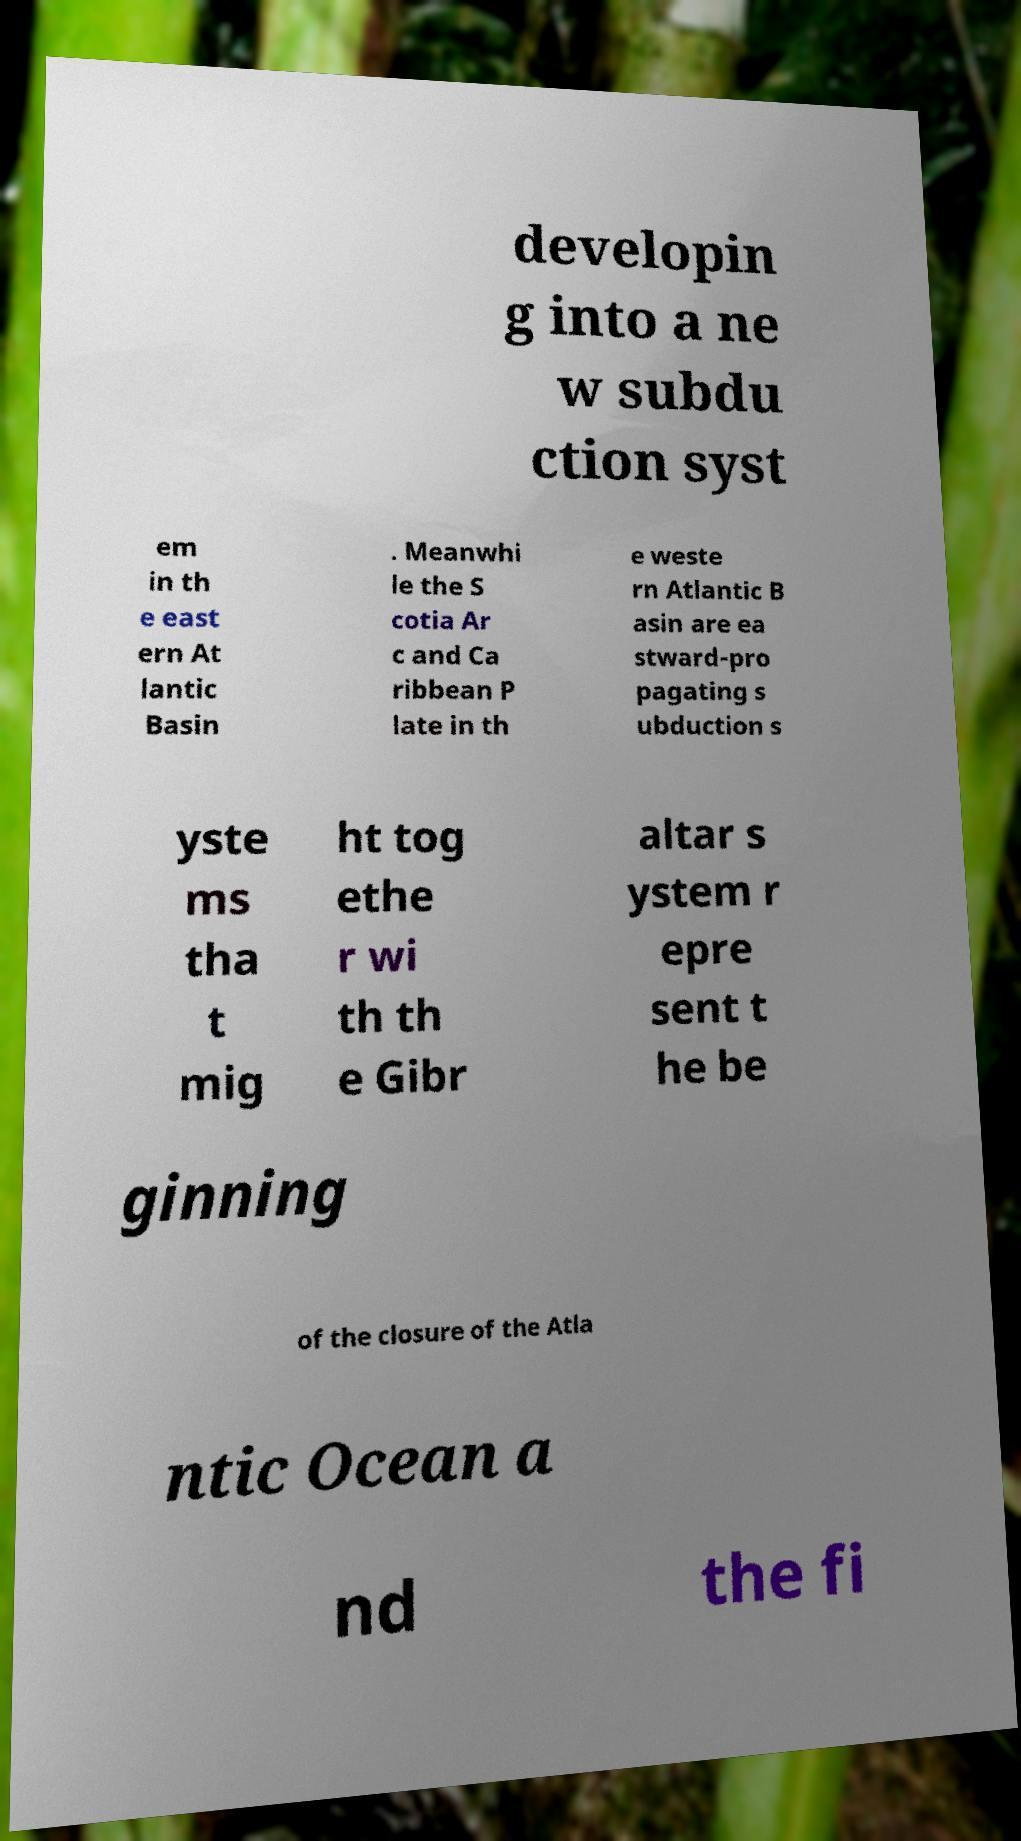Please read and relay the text visible in this image. What does it say? developin g into a ne w subdu ction syst em in th e east ern At lantic Basin . Meanwhi le the S cotia Ar c and Ca ribbean P late in th e weste rn Atlantic B asin are ea stward-pro pagating s ubduction s yste ms tha t mig ht tog ethe r wi th th e Gibr altar s ystem r epre sent t he be ginning of the closure of the Atla ntic Ocean a nd the fi 